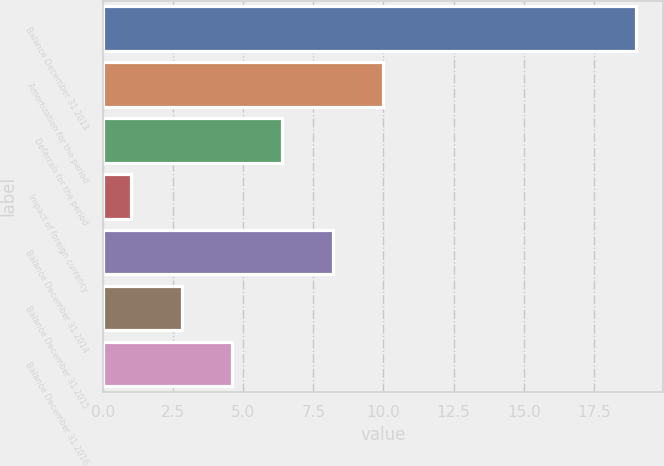Convert chart. <chart><loc_0><loc_0><loc_500><loc_500><bar_chart><fcel>Balance December 31 2013<fcel>Amortization for the period<fcel>Deferrals for the period<fcel>Impact of foreign currency<fcel>Balance December 31 2014<fcel>Balance December 31 2015<fcel>Balance December 31 2016<nl><fcel>19<fcel>10<fcel>6.4<fcel>1<fcel>8.2<fcel>2.8<fcel>4.6<nl></chart> 